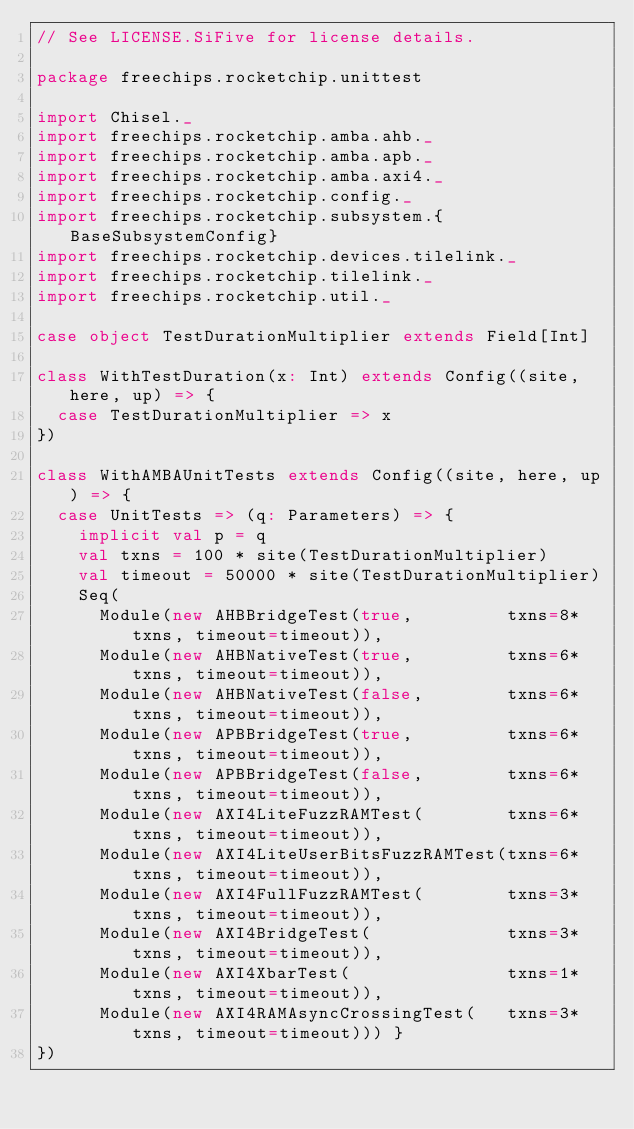Convert code to text. <code><loc_0><loc_0><loc_500><loc_500><_Scala_>// See LICENSE.SiFive for license details.

package freechips.rocketchip.unittest

import Chisel._
import freechips.rocketchip.amba.ahb._
import freechips.rocketchip.amba.apb._
import freechips.rocketchip.amba.axi4._
import freechips.rocketchip.config._
import freechips.rocketchip.subsystem.{BaseSubsystemConfig}
import freechips.rocketchip.devices.tilelink._
import freechips.rocketchip.tilelink._
import freechips.rocketchip.util._

case object TestDurationMultiplier extends Field[Int]

class WithTestDuration(x: Int) extends Config((site, here, up) => {
  case TestDurationMultiplier => x
})

class WithAMBAUnitTests extends Config((site, here, up) => {
  case UnitTests => (q: Parameters) => {
    implicit val p = q
    val txns = 100 * site(TestDurationMultiplier)
    val timeout = 50000 * site(TestDurationMultiplier)
    Seq(
      Module(new AHBBridgeTest(true,         txns=8*txns, timeout=timeout)),
      Module(new AHBNativeTest(true,         txns=6*txns, timeout=timeout)),
      Module(new AHBNativeTest(false,        txns=6*txns, timeout=timeout)),
      Module(new APBBridgeTest(true,         txns=6*txns, timeout=timeout)),
      Module(new APBBridgeTest(false,        txns=6*txns, timeout=timeout)),
      Module(new AXI4LiteFuzzRAMTest(        txns=6*txns, timeout=timeout)),
      Module(new AXI4LiteUserBitsFuzzRAMTest(txns=6*txns, timeout=timeout)),
      Module(new AXI4FullFuzzRAMTest(        txns=3*txns, timeout=timeout)),
      Module(new AXI4BridgeTest(             txns=3*txns, timeout=timeout)),
      Module(new AXI4XbarTest(               txns=1*txns, timeout=timeout)),
      Module(new AXI4RAMAsyncCrossingTest(   txns=3*txns, timeout=timeout))) }
})
</code> 